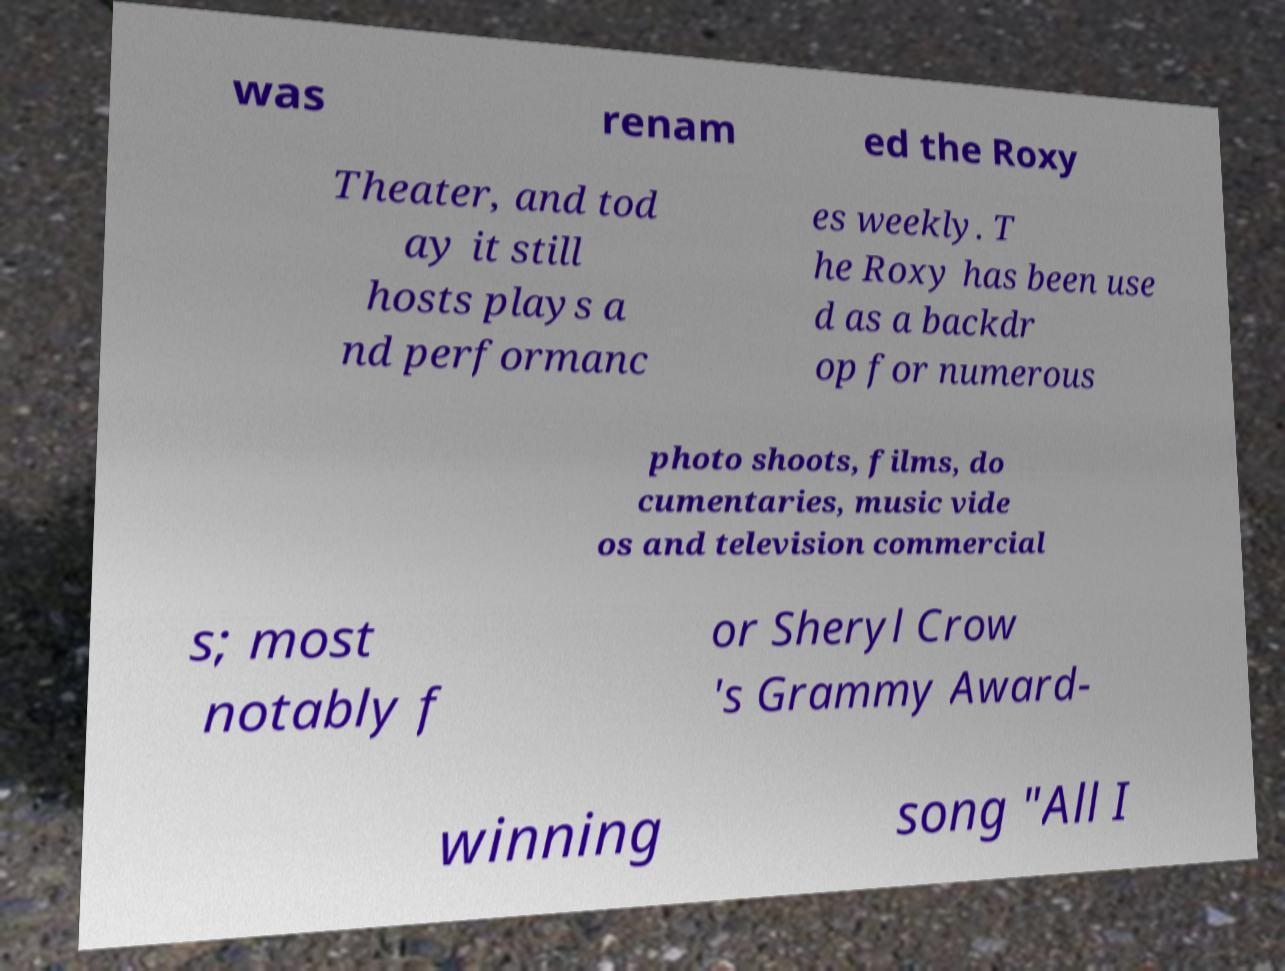Can you read and provide the text displayed in the image?This photo seems to have some interesting text. Can you extract and type it out for me? was renam ed the Roxy Theater, and tod ay it still hosts plays a nd performanc es weekly. T he Roxy has been use d as a backdr op for numerous photo shoots, films, do cumentaries, music vide os and television commercial s; most notably f or Sheryl Crow 's Grammy Award- winning song "All I 